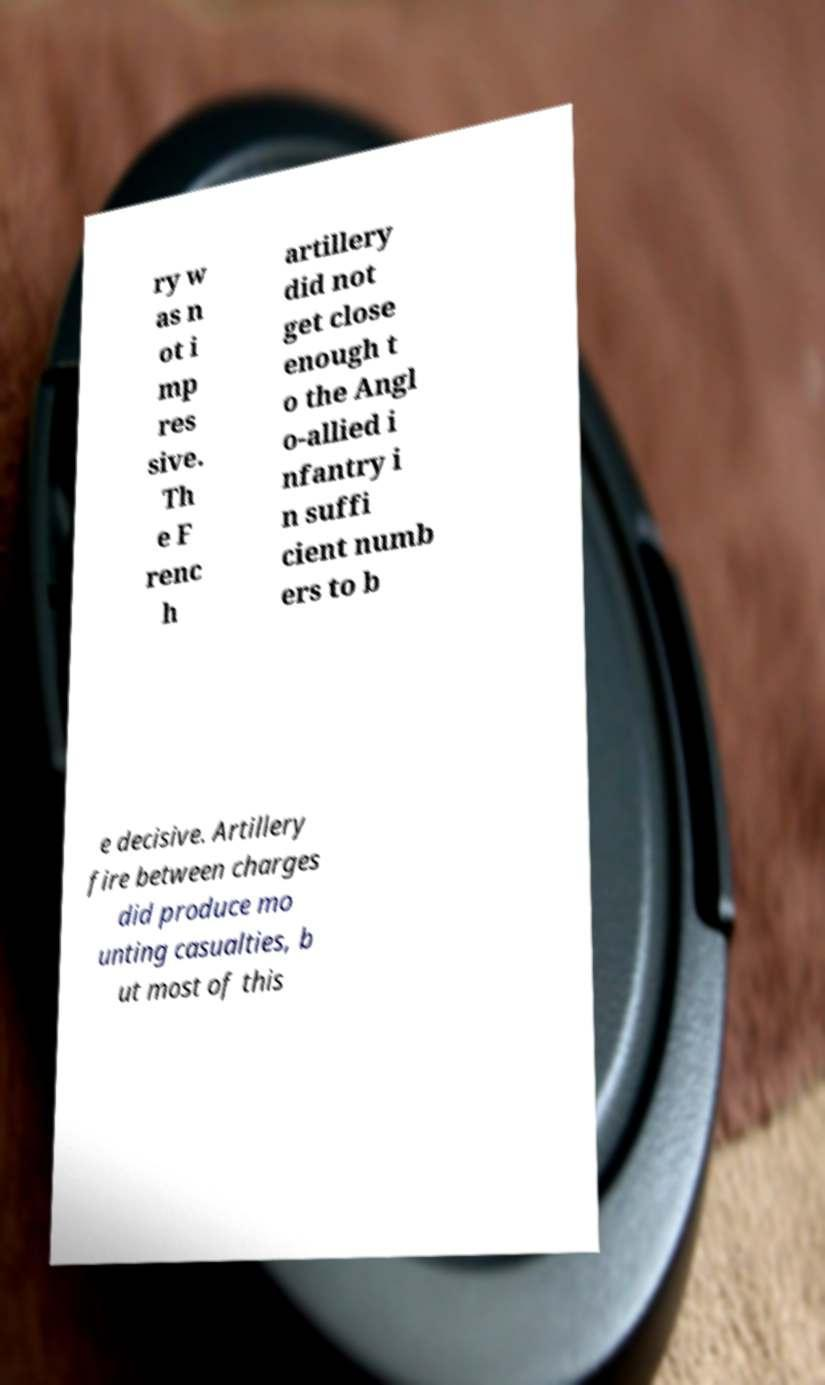Could you extract and type out the text from this image? ry w as n ot i mp res sive. Th e F renc h artillery did not get close enough t o the Angl o-allied i nfantry i n suffi cient numb ers to b e decisive. Artillery fire between charges did produce mo unting casualties, b ut most of this 